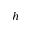<formula> <loc_0><loc_0><loc_500><loc_500>_ { h }</formula> 